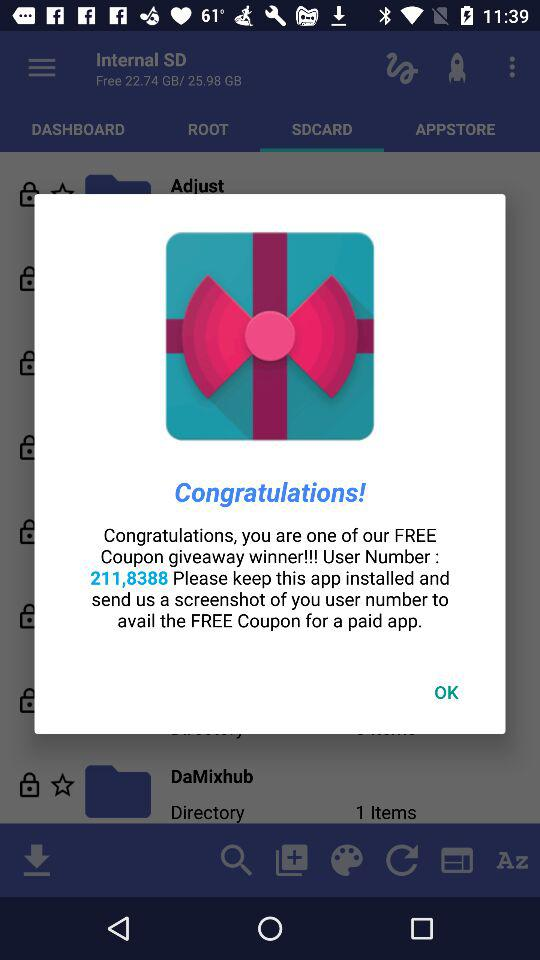What is the user number? The user number is 211,8388. 